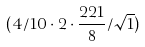<formula> <loc_0><loc_0><loc_500><loc_500>( 4 / 1 0 \cdot 2 \cdot \frac { 2 2 1 } { 8 } / \sqrt { 1 } )</formula> 